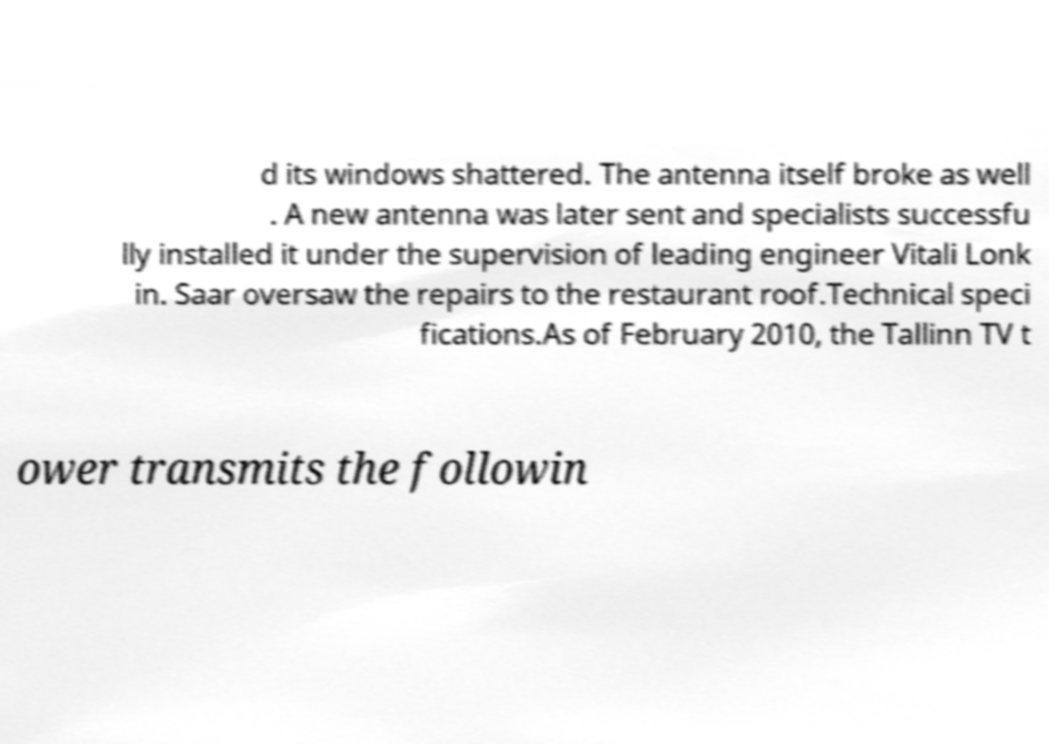I need the written content from this picture converted into text. Can you do that? d its windows shattered. The antenna itself broke as well . A new antenna was later sent and specialists successfu lly installed it under the supervision of leading engineer Vitali Lonk in. Saar oversaw the repairs to the restaurant roof.Technical speci fications.As of February 2010, the Tallinn TV t ower transmits the followin 